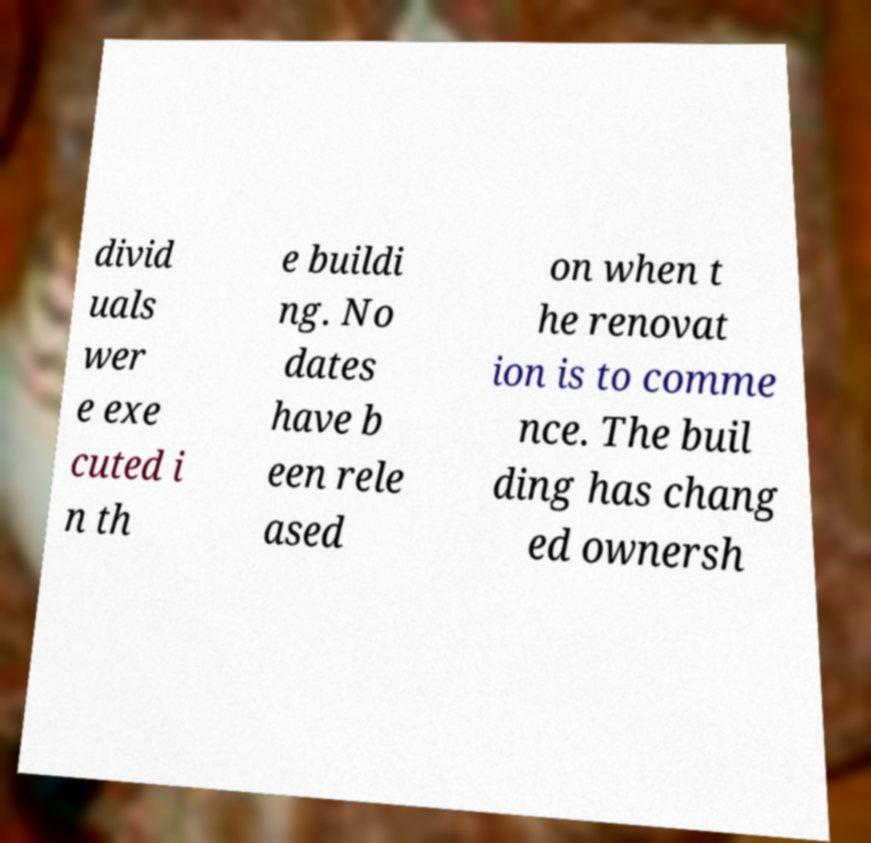Please identify and transcribe the text found in this image. divid uals wer e exe cuted i n th e buildi ng. No dates have b een rele ased on when t he renovat ion is to comme nce. The buil ding has chang ed ownersh 